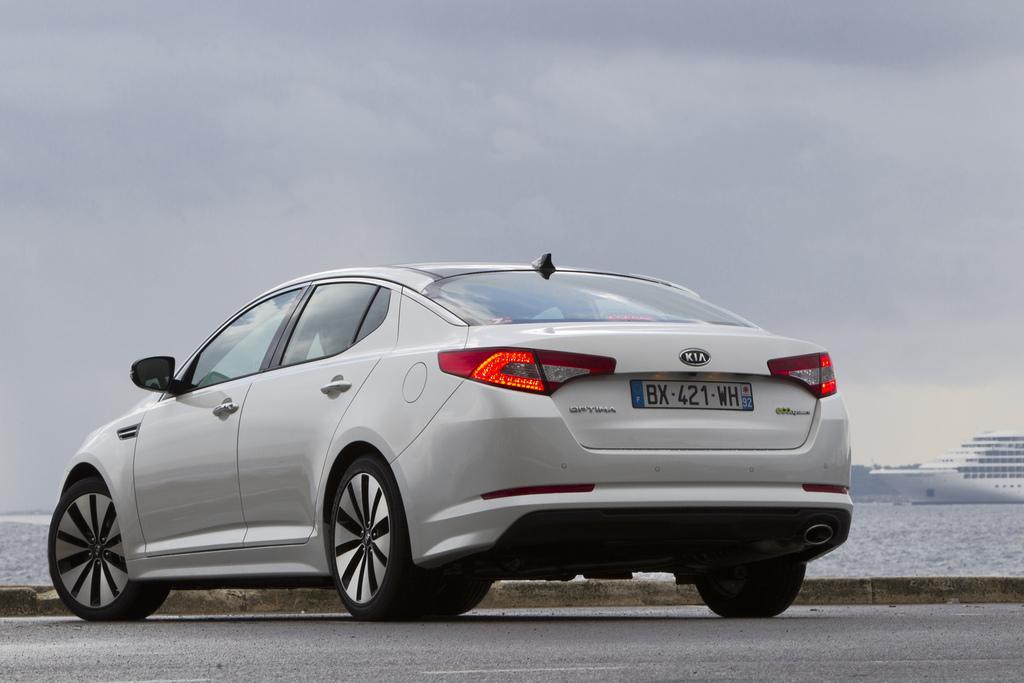How would you summarize this image in a sentence or two? In this image we can see a car which is in white color on the road and there is a ship on the water in the background of the image and at the top we can see the sky. 